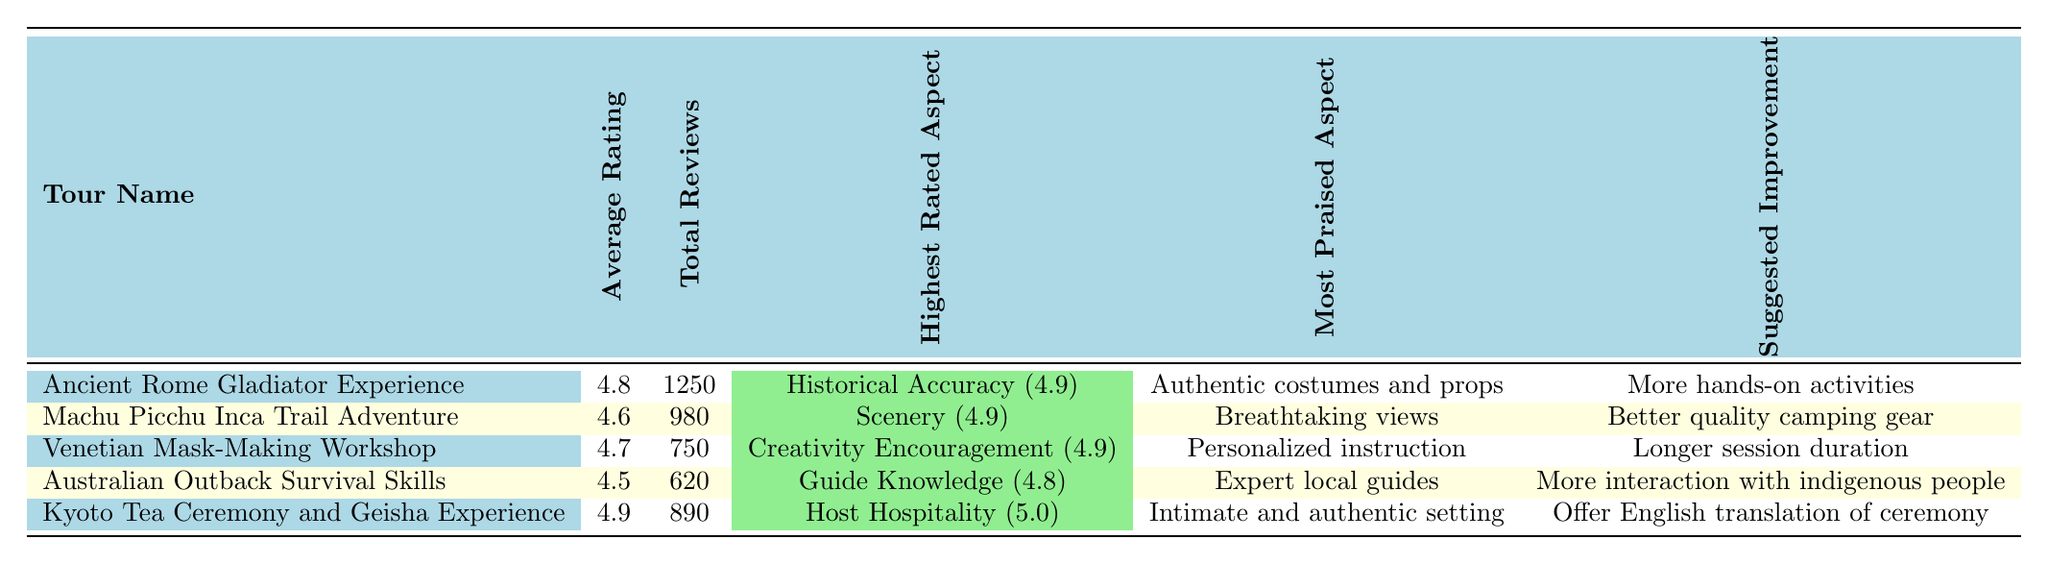What is the average rating of the "Ancient Rome Gladiator Experience"? The table shows that the "Ancient Rome Gladiator Experience" has an average rating of 4.8.
Answer: 4.8 How many total reviews did the "Machu Picchu Inca Trail Adventure" receive? The total reviews for the "Machu Picchu Inca Trail Adventure" are listed in the table as 980.
Answer: 980 Which tour has the highest average rating? The "Kyoto Tea Ceremony and Geisha Experience" has the highest average rating of 4.9 as per the table.
Answer: Kyoto Tea Ceremony and Geisha Experience What is the difference between the average ratings of the "Australian Outback Survival Skills" and the "Venetian Mask-Making Workshop"? The average rating for the "Australian Outback Survival Skills" is 4.5 and for the "Venetian Mask-Making Workshop" it is 4.7. The difference is calculated as 4.7 - 4.5 = 0.2.
Answer: 0.2 Is the "Host Hospitality" category rated higher than 4.5 in any tour? According to the table, the "Host Hospitality" category for the "Kyoto Tea Ceremony and Geisha Experience" is rated 5.0, which is higher than 4.5.
Answer: Yes How many total reviews did tours with an average rating of 4.6 or higher receive? The tours with ratings of 4.6 or higher are "Ancient Rome Gladiator Experience" (1250), "Machu Picchu Inca Trail Adventure" (980), "Venetian Mask-Making Workshop" (750), and "Kyoto Tea Ceremony and Geisha Experience" (890). Summing these gives 1250 + 980 + 750 + 890 = 3870.
Answer: 3870 Which tour received the most reviews? The "Ancient Rome Gladiator Experience" received the most reviews, totaling 1250 as per the table.
Answer: Ancient Rome Gladiator Experience What suggested improvement was mentioned for the "Venetian Mask-Making Workshop"? The suggested improvement for the "Venetian Mask-Making Workshop" in the table is a "Longer session duration."
Answer: Longer session duration How do the average ratings of the "Machu Picchu Inca Trail Adventure" and "Australian Outback Survival Skills" compare? The average rating for "Machu Picchu Inca Trail Adventure" is 4.6 and for "Australian Outback Survival Skills" it is 4.5. Since 4.6 is greater than 4.5, the "Machu Picchu Inca Trail Adventure" has a higher average rating.
Answer: Machu Picchu Inca Trail Adventure is higher 